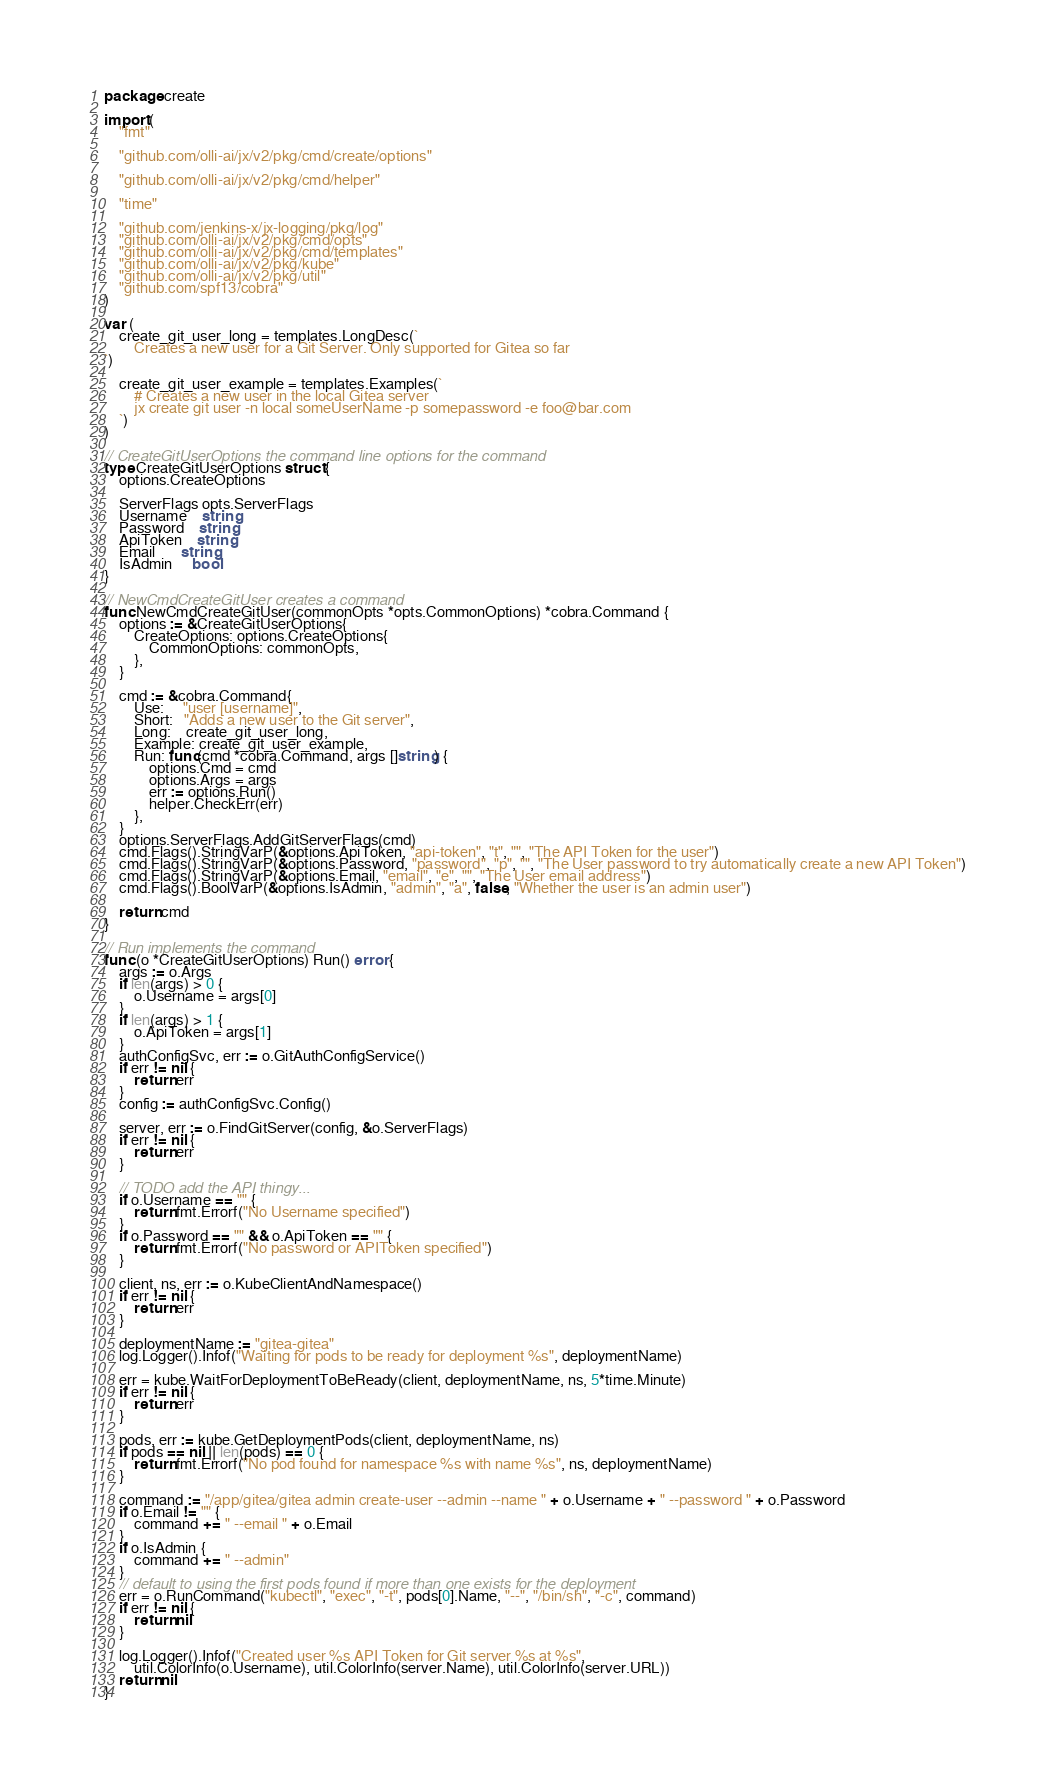<code> <loc_0><loc_0><loc_500><loc_500><_Go_>package create

import (
	"fmt"

	"github.com/olli-ai/jx/v2/pkg/cmd/create/options"

	"github.com/olli-ai/jx/v2/pkg/cmd/helper"

	"time"

	"github.com/jenkins-x/jx-logging/pkg/log"
	"github.com/olli-ai/jx/v2/pkg/cmd/opts"
	"github.com/olli-ai/jx/v2/pkg/cmd/templates"
	"github.com/olli-ai/jx/v2/pkg/kube"
	"github.com/olli-ai/jx/v2/pkg/util"
	"github.com/spf13/cobra"
)

var (
	create_git_user_long = templates.LongDesc(`
		Creates a new user for a Git Server. Only supported for Gitea so far
`)

	create_git_user_example = templates.Examples(`
		# Creates a new user in the local Gitea server
		jx create git user -n local someUserName -p somepassword -e foo@bar.com
	`)
)

// CreateGitUserOptions the command line options for the command
type CreateGitUserOptions struct {
	options.CreateOptions

	ServerFlags opts.ServerFlags
	Username    string
	Password    string
	ApiToken    string
	Email       string
	IsAdmin     bool
}

// NewCmdCreateGitUser creates a command
func NewCmdCreateGitUser(commonOpts *opts.CommonOptions) *cobra.Command {
	options := &CreateGitUserOptions{
		CreateOptions: options.CreateOptions{
			CommonOptions: commonOpts,
		},
	}

	cmd := &cobra.Command{
		Use:     "user [username]",
		Short:   "Adds a new user to the Git server",
		Long:    create_git_user_long,
		Example: create_git_user_example,
		Run: func(cmd *cobra.Command, args []string) {
			options.Cmd = cmd
			options.Args = args
			err := options.Run()
			helper.CheckErr(err)
		},
	}
	options.ServerFlags.AddGitServerFlags(cmd)
	cmd.Flags().StringVarP(&options.ApiToken, "api-token", "t", "", "The API Token for the user")
	cmd.Flags().StringVarP(&options.Password, "password", "p", "", "The User password to try automatically create a new API Token")
	cmd.Flags().StringVarP(&options.Email, "email", "e", "", "The User email address")
	cmd.Flags().BoolVarP(&options.IsAdmin, "admin", "a", false, "Whether the user is an admin user")

	return cmd
}

// Run implements the command
func (o *CreateGitUserOptions) Run() error {
	args := o.Args
	if len(args) > 0 {
		o.Username = args[0]
	}
	if len(args) > 1 {
		o.ApiToken = args[1]
	}
	authConfigSvc, err := o.GitAuthConfigService()
	if err != nil {
		return err
	}
	config := authConfigSvc.Config()

	server, err := o.FindGitServer(config, &o.ServerFlags)
	if err != nil {
		return err
	}

	// TODO add the API thingy...
	if o.Username == "" {
		return fmt.Errorf("No Username specified")
	}
	if o.Password == "" && o.ApiToken == "" {
		return fmt.Errorf("No password or APIToken specified")
	}

	client, ns, err := o.KubeClientAndNamespace()
	if err != nil {
		return err
	}

	deploymentName := "gitea-gitea"
	log.Logger().Infof("Waiting for pods to be ready for deployment %s", deploymentName)

	err = kube.WaitForDeploymentToBeReady(client, deploymentName, ns, 5*time.Minute)
	if err != nil {
		return err
	}

	pods, err := kube.GetDeploymentPods(client, deploymentName, ns)
	if pods == nil || len(pods) == 0 {
		return fmt.Errorf("No pod found for namespace %s with name %s", ns, deploymentName)
	}

	command := "/app/gitea/gitea admin create-user --admin --name " + o.Username + " --password " + o.Password
	if o.Email != "" {
		command += " --email " + o.Email
	}
	if o.IsAdmin {
		command += " --admin"
	}
	// default to using the first pods found if more than one exists for the deployment
	err = o.RunCommand("kubectl", "exec", "-t", pods[0].Name, "--", "/bin/sh", "-c", command)
	if err != nil {
		return nil
	}

	log.Logger().Infof("Created user %s API Token for Git server %s at %s",
		util.ColorInfo(o.Username), util.ColorInfo(server.Name), util.ColorInfo(server.URL))
	return nil
}
</code> 